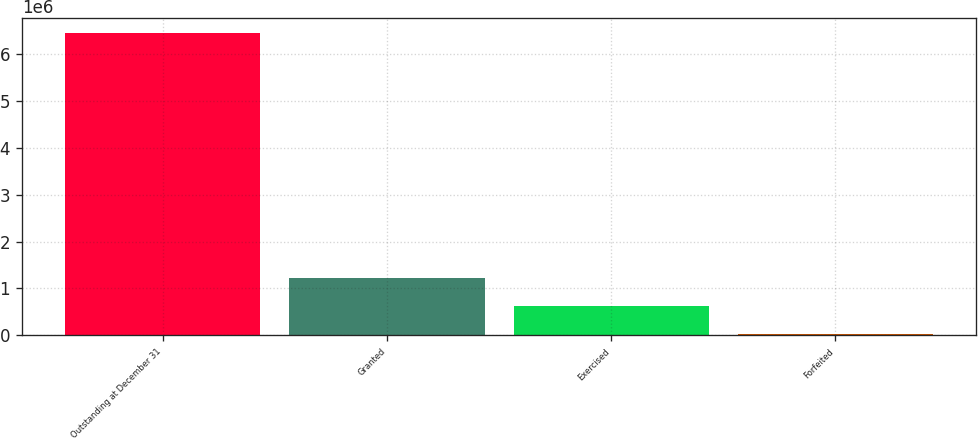Convert chart. <chart><loc_0><loc_0><loc_500><loc_500><bar_chart><fcel>Outstanding at December 31<fcel>Granted<fcel>Exercised<fcel>Forfeited<nl><fcel>6.43432e+06<fcel>1.22472e+06<fcel>621713<fcel>18710<nl></chart> 